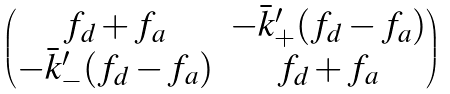Convert formula to latex. <formula><loc_0><loc_0><loc_500><loc_500>\begin{pmatrix} f _ { d } + f _ { a } & - { \bar { k } } ^ { \prime } _ { + } ( f _ { d } - f _ { a } ) \\ - { \bar { k } } ^ { \prime } _ { - } ( f _ { d } - f _ { a } ) & f _ { d } + f _ { a } \end{pmatrix}</formula> 